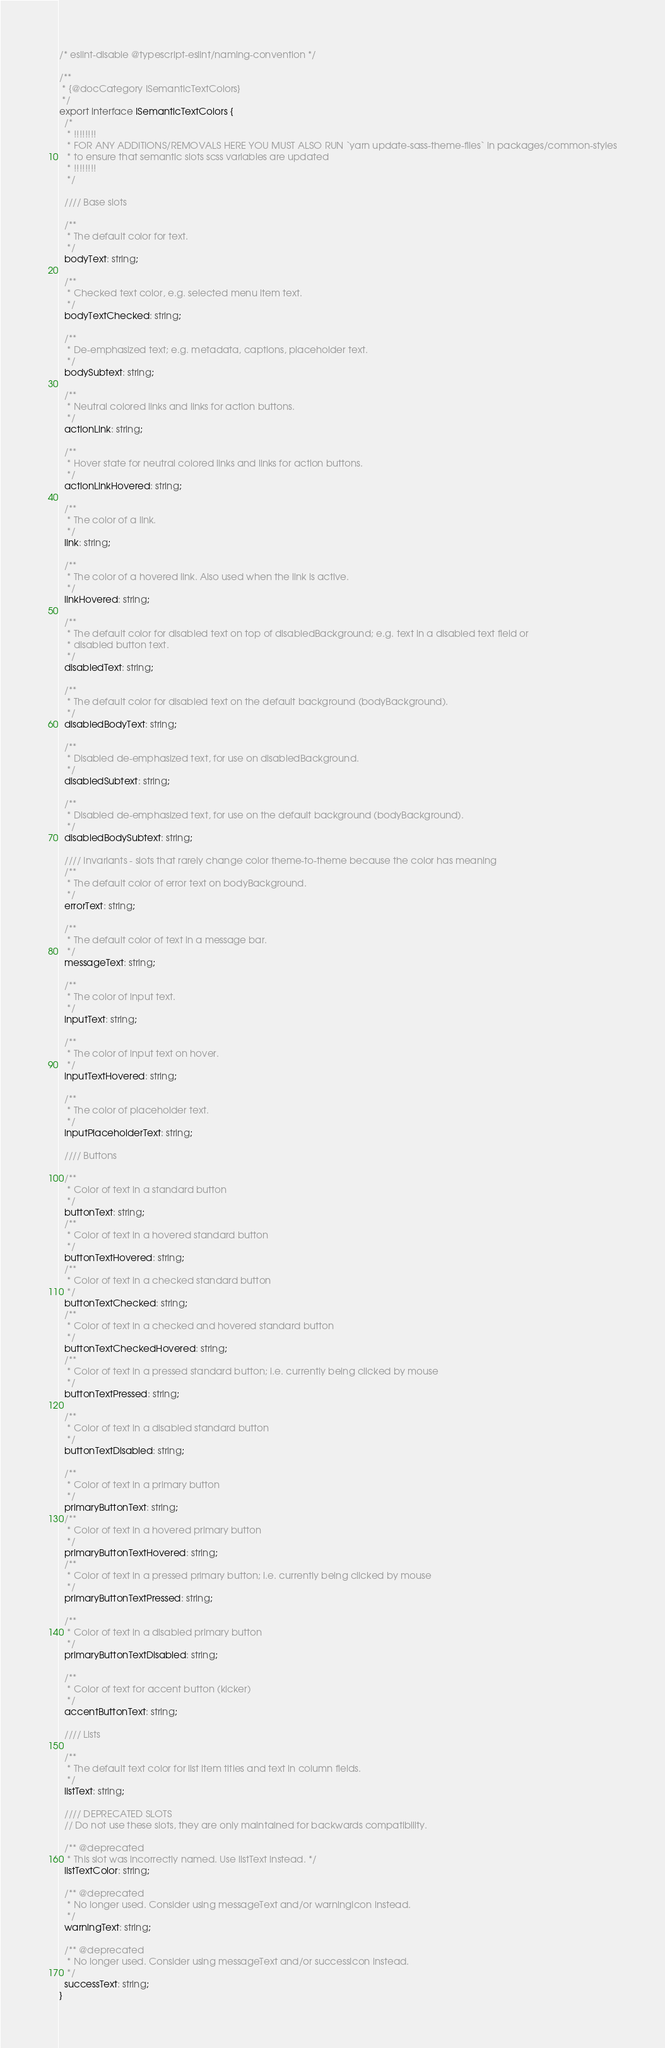<code> <loc_0><loc_0><loc_500><loc_500><_TypeScript_>/* eslint-disable @typescript-eslint/naming-convention */

/**
 * {@docCategory ISemanticTextColors}
 */
export interface ISemanticTextColors {
  /*
   * !!!!!!!!
   * FOR ANY ADDITIONS/REMOVALS HERE YOU MUST ALSO RUN `yarn update-sass-theme-files` in packages/common-styles
   * to ensure that semantic slots scss variables are updated
   * !!!!!!!!
   */

  //// Base slots

  /**
   * The default color for text.
   */
  bodyText: string;

  /**
   * Checked text color, e.g. selected menu item text.
   */
  bodyTextChecked: string;

  /**
   * De-emphasized text; e.g. metadata, captions, placeholder text.
   */
  bodySubtext: string;

  /**
   * Neutral colored links and links for action buttons.
   */
  actionLink: string;

  /**
   * Hover state for neutral colored links and links for action buttons.
   */
  actionLinkHovered: string;

  /**
   * The color of a link.
   */
  link: string;

  /**
   * The color of a hovered link. Also used when the link is active.
   */
  linkHovered: string;

  /**
   * The default color for disabled text on top of disabledBackground; e.g. text in a disabled text field or
   * disabled button text.
   */
  disabledText: string;

  /**
   * The default color for disabled text on the default background (bodyBackground).
   */
  disabledBodyText: string;

  /**
   * Disabled de-emphasized text, for use on disabledBackground.
   */
  disabledSubtext: string;

  /**
   * Disabled de-emphasized text, for use on the default background (bodyBackground).
   */
  disabledBodySubtext: string;

  //// Invariants - slots that rarely change color theme-to-theme because the color has meaning
  /**
   * The default color of error text on bodyBackground.
   */
  errorText: string;

  /**
   * The default color of text in a message bar.
   */
  messageText: string;

  /**
   * The color of input text.
   */
  inputText: string;

  /**
   * The color of input text on hover.
   */
  inputTextHovered: string;

  /**
   * The color of placeholder text.
   */
  inputPlaceholderText: string;

  //// Buttons

  /**
   * Color of text in a standard button
   */
  buttonText: string;
  /**
   * Color of text in a hovered standard button
   */
  buttonTextHovered: string;
  /**
   * Color of text in a checked standard button
   */
  buttonTextChecked: string;
  /**
   * Color of text in a checked and hovered standard button
   */
  buttonTextCheckedHovered: string;
  /**
   * Color of text in a pressed standard button; i.e. currently being clicked by mouse
   */
  buttonTextPressed: string;

  /**
   * Color of text in a disabled standard button
   */
  buttonTextDisabled: string;

  /**
   * Color of text in a primary button
   */
  primaryButtonText: string;
  /**
   * Color of text in a hovered primary button
   */
  primaryButtonTextHovered: string;
  /**
   * Color of text in a pressed primary button; i.e. currently being clicked by mouse
   */
  primaryButtonTextPressed: string;

  /**
   * Color of text in a disabled primary button
   */
  primaryButtonTextDisabled: string;

  /**
   * Color of text for accent button (kicker)
   */
  accentButtonText: string;

  //// Lists

  /**
   * The default text color for list item titles and text in column fields.
   */
  listText: string;

  //// DEPRECATED SLOTS
  // Do not use these slots, they are only maintained for backwards compatibility.

  /** @deprecated
   * This slot was incorrectly named. Use listText instead. */
  listTextColor: string;

  /** @deprecated
   * No longer used. Consider using messageText and/or warningIcon instead.
   */
  warningText: string;

  /** @deprecated
   * No longer used. Consider using messageText and/or successIcon instead.
   */
  successText: string;
}
</code> 